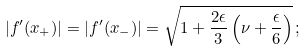Convert formula to latex. <formula><loc_0><loc_0><loc_500><loc_500>| f ^ { \prime } ( x _ { + } ) | = | f ^ { \prime } ( x _ { - } ) | = \sqrt { 1 + \frac { 2 \epsilon } { 3 } \left ( \nu + \frac { \epsilon } { 6 } \right ) } \, ;</formula> 